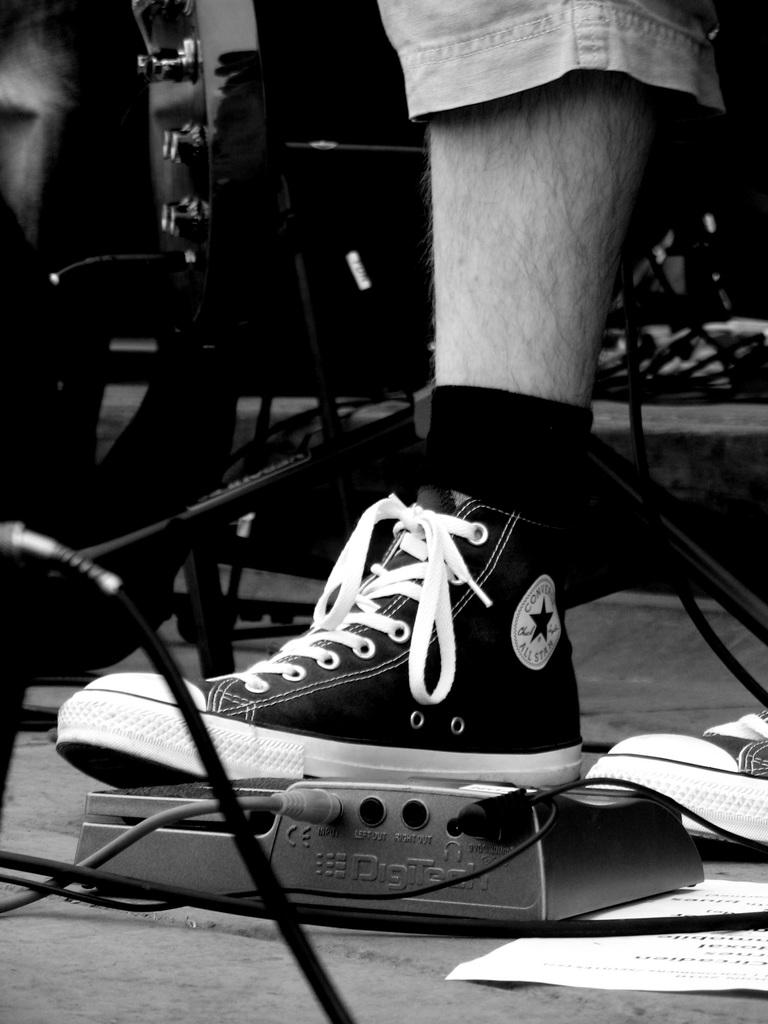What part of a person's body can be seen in the image? There is a person's leg visible in the image. What is the person wearing on their feet? The person is wearing shoes. What type of coal is being used to fuel the show in the image? There is no coal or show present in the image; it only features a person's leg and shoes. 